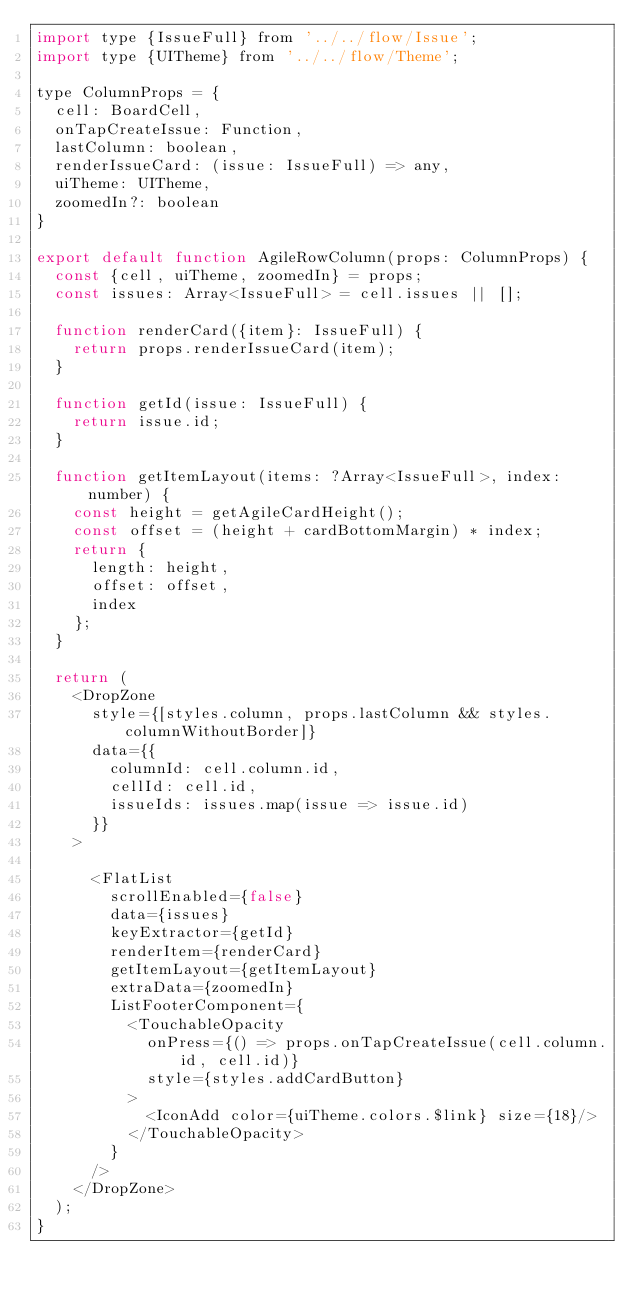<code> <loc_0><loc_0><loc_500><loc_500><_JavaScript_>import type {IssueFull} from '../../flow/Issue';
import type {UITheme} from '../../flow/Theme';

type ColumnProps = {
  cell: BoardCell,
  onTapCreateIssue: Function,
  lastColumn: boolean,
  renderIssueCard: (issue: IssueFull) => any,
  uiTheme: UITheme,
  zoomedIn?: boolean
}

export default function AgileRowColumn(props: ColumnProps) {
  const {cell, uiTheme, zoomedIn} = props;
  const issues: Array<IssueFull> = cell.issues || [];

  function renderCard({item}: IssueFull) {
    return props.renderIssueCard(item);
  }

  function getId(issue: IssueFull) {
    return issue.id;
  }

  function getItemLayout(items: ?Array<IssueFull>, index: number) {
    const height = getAgileCardHeight();
    const offset = (height + cardBottomMargin) * index;
    return {
      length: height,
      offset: offset,
      index
    };
  }

  return (
    <DropZone
      style={[styles.column, props.lastColumn && styles.columnWithoutBorder]}
      data={{
        columnId: cell.column.id,
        cellId: cell.id,
        issueIds: issues.map(issue => issue.id)
      }}
    >

      <FlatList
        scrollEnabled={false}
        data={issues}
        keyExtractor={getId}
        renderItem={renderCard}
        getItemLayout={getItemLayout}
        extraData={zoomedIn}
        ListFooterComponent={
          <TouchableOpacity
            onPress={() => props.onTapCreateIssue(cell.column.id, cell.id)}
            style={styles.addCardButton}
          >
            <IconAdd color={uiTheme.colors.$link} size={18}/>
          </TouchableOpacity>
        }
      />
    </DropZone>
  );
}
</code> 